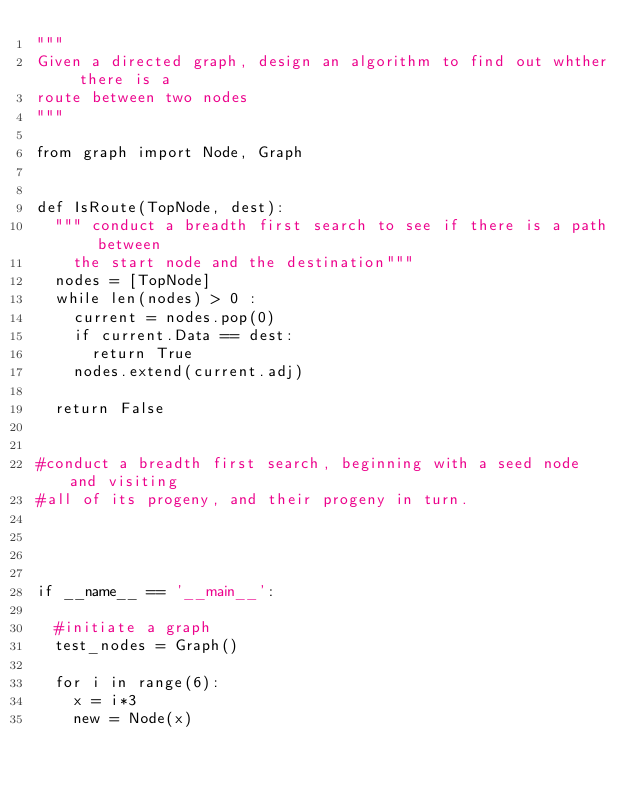Convert code to text. <code><loc_0><loc_0><loc_500><loc_500><_Python_>"""
Given a directed graph, design an algorithm to find out whther there is a 
route between two nodes
"""

from graph import Node, Graph


def IsRoute(TopNode, dest):
	""" conduct a breadth first search to see if there is a path between
		the start node and the destination"""
	nodes = [TopNode]
	while len(nodes) > 0 :
		current = nodes.pop(0)
		if current.Data == dest:
			return True
		nodes.extend(current.adj)

	return False


#conduct a breadth first search, beginning with a seed node and visiting
#all of its progeny, and their progeny in turn.




if __name__ == '__main__':

	#initiate a graph
	test_nodes = Graph()

	for i in range(6):
		x = i*3
		new = Node(x)
</code> 